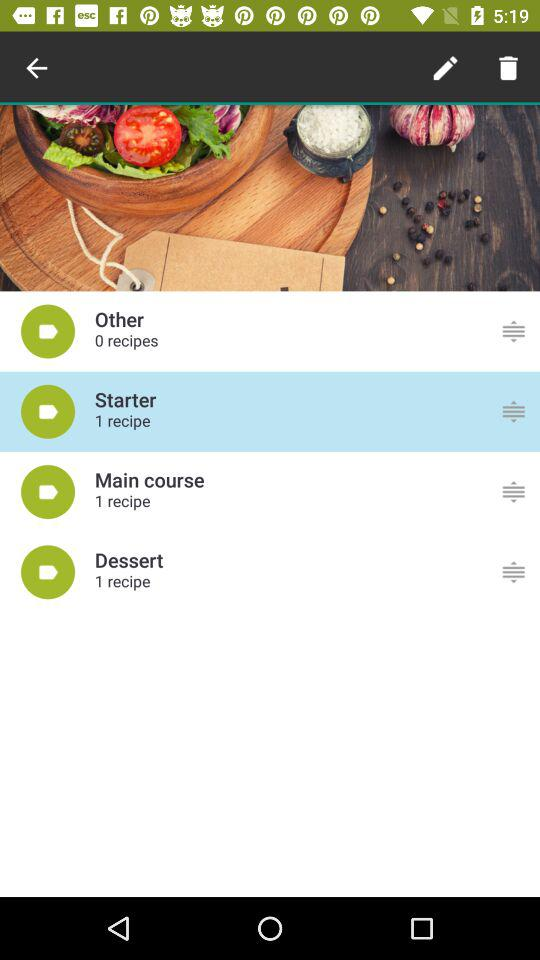How many recipes are there in the desert? There is 1 recipe in the desert. 